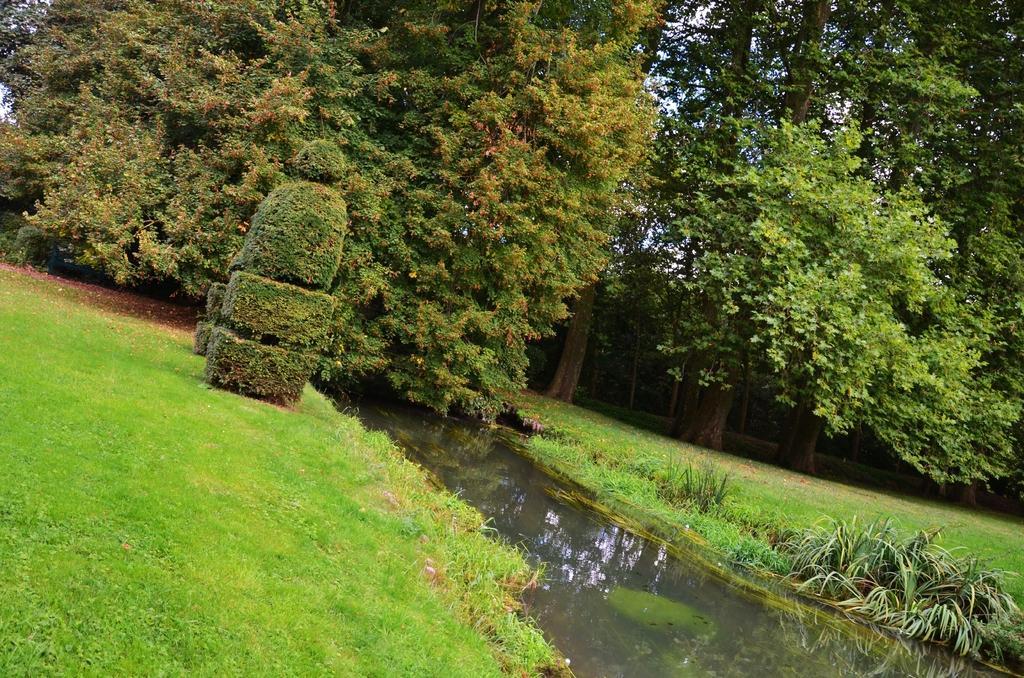How would you summarize this image in a sentence or two? There is grass, water and trees. 